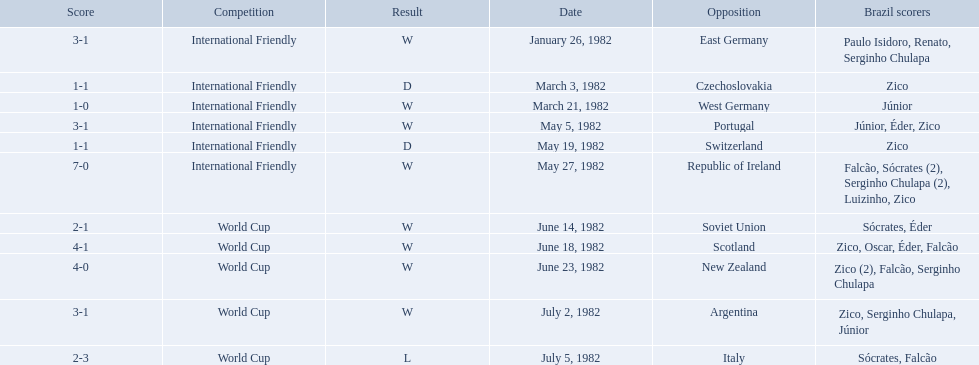How many goals did brazil score against the soviet union? 2-1. How many goals did brazil score against portugal? 3-1. Did brazil score more goals against portugal or the soviet union? Portugal. 